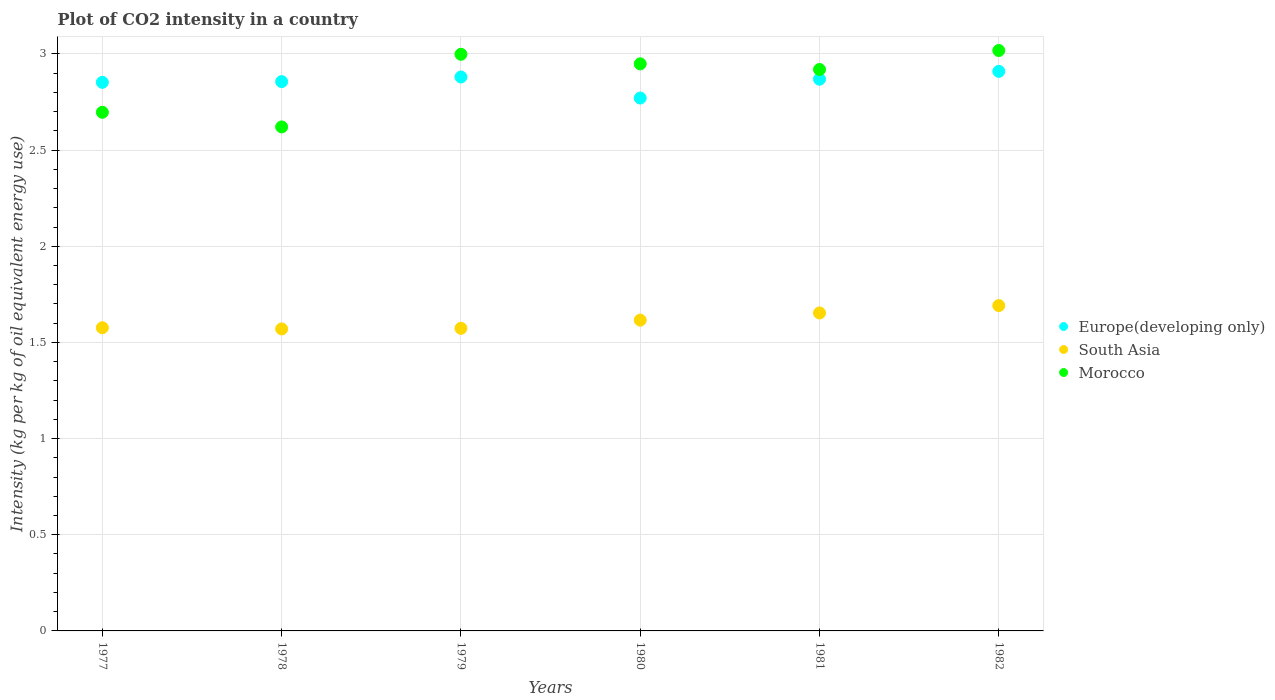How many different coloured dotlines are there?
Ensure brevity in your answer.  3. What is the CO2 intensity in in Europe(developing only) in 1980?
Keep it short and to the point. 2.77. Across all years, what is the maximum CO2 intensity in in South Asia?
Provide a short and direct response. 1.69. Across all years, what is the minimum CO2 intensity in in South Asia?
Your answer should be compact. 1.57. In which year was the CO2 intensity in in Morocco minimum?
Offer a very short reply. 1978. What is the total CO2 intensity in in Morocco in the graph?
Provide a short and direct response. 17.2. What is the difference between the CO2 intensity in in South Asia in 1978 and that in 1979?
Give a very brief answer. -0. What is the difference between the CO2 intensity in in Morocco in 1979 and the CO2 intensity in in South Asia in 1981?
Your answer should be very brief. 1.35. What is the average CO2 intensity in in South Asia per year?
Your response must be concise. 1.61. In the year 1980, what is the difference between the CO2 intensity in in Europe(developing only) and CO2 intensity in in Morocco?
Provide a succinct answer. -0.18. In how many years, is the CO2 intensity in in Morocco greater than 2 kg?
Make the answer very short. 6. What is the ratio of the CO2 intensity in in Morocco in 1979 to that in 1981?
Make the answer very short. 1.03. Is the difference between the CO2 intensity in in Europe(developing only) in 1979 and 1980 greater than the difference between the CO2 intensity in in Morocco in 1979 and 1980?
Provide a short and direct response. Yes. What is the difference between the highest and the second highest CO2 intensity in in Europe(developing only)?
Your answer should be compact. 0.03. What is the difference between the highest and the lowest CO2 intensity in in Europe(developing only)?
Your answer should be very brief. 0.14. In how many years, is the CO2 intensity in in Morocco greater than the average CO2 intensity in in Morocco taken over all years?
Offer a very short reply. 4. Is the sum of the CO2 intensity in in Europe(developing only) in 1977 and 1978 greater than the maximum CO2 intensity in in Morocco across all years?
Provide a succinct answer. Yes. Is it the case that in every year, the sum of the CO2 intensity in in Morocco and CO2 intensity in in South Asia  is greater than the CO2 intensity in in Europe(developing only)?
Make the answer very short. Yes. Does the CO2 intensity in in Morocco monotonically increase over the years?
Ensure brevity in your answer.  No. What is the difference between two consecutive major ticks on the Y-axis?
Your answer should be very brief. 0.5. Are the values on the major ticks of Y-axis written in scientific E-notation?
Provide a succinct answer. No. Does the graph contain any zero values?
Make the answer very short. No. Does the graph contain grids?
Your response must be concise. Yes. Where does the legend appear in the graph?
Provide a succinct answer. Center right. How are the legend labels stacked?
Keep it short and to the point. Vertical. What is the title of the graph?
Your answer should be compact. Plot of CO2 intensity in a country. What is the label or title of the X-axis?
Offer a terse response. Years. What is the label or title of the Y-axis?
Give a very brief answer. Intensity (kg per kg of oil equivalent energy use). What is the Intensity (kg per kg of oil equivalent energy use) of Europe(developing only) in 1977?
Offer a terse response. 2.85. What is the Intensity (kg per kg of oil equivalent energy use) in South Asia in 1977?
Keep it short and to the point. 1.58. What is the Intensity (kg per kg of oil equivalent energy use) in Morocco in 1977?
Provide a short and direct response. 2.7. What is the Intensity (kg per kg of oil equivalent energy use) in Europe(developing only) in 1978?
Ensure brevity in your answer.  2.86. What is the Intensity (kg per kg of oil equivalent energy use) of South Asia in 1978?
Ensure brevity in your answer.  1.57. What is the Intensity (kg per kg of oil equivalent energy use) in Morocco in 1978?
Provide a succinct answer. 2.62. What is the Intensity (kg per kg of oil equivalent energy use) of Europe(developing only) in 1979?
Provide a short and direct response. 2.88. What is the Intensity (kg per kg of oil equivalent energy use) of South Asia in 1979?
Offer a very short reply. 1.57. What is the Intensity (kg per kg of oil equivalent energy use) in Morocco in 1979?
Provide a succinct answer. 3. What is the Intensity (kg per kg of oil equivalent energy use) of Europe(developing only) in 1980?
Offer a very short reply. 2.77. What is the Intensity (kg per kg of oil equivalent energy use) in South Asia in 1980?
Keep it short and to the point. 1.62. What is the Intensity (kg per kg of oil equivalent energy use) of Morocco in 1980?
Your answer should be compact. 2.95. What is the Intensity (kg per kg of oil equivalent energy use) of Europe(developing only) in 1981?
Offer a very short reply. 2.87. What is the Intensity (kg per kg of oil equivalent energy use) of South Asia in 1981?
Give a very brief answer. 1.65. What is the Intensity (kg per kg of oil equivalent energy use) of Morocco in 1981?
Your answer should be very brief. 2.92. What is the Intensity (kg per kg of oil equivalent energy use) of Europe(developing only) in 1982?
Provide a short and direct response. 2.91. What is the Intensity (kg per kg of oil equivalent energy use) in South Asia in 1982?
Your answer should be very brief. 1.69. What is the Intensity (kg per kg of oil equivalent energy use) in Morocco in 1982?
Provide a short and direct response. 3.02. Across all years, what is the maximum Intensity (kg per kg of oil equivalent energy use) of Europe(developing only)?
Provide a succinct answer. 2.91. Across all years, what is the maximum Intensity (kg per kg of oil equivalent energy use) of South Asia?
Keep it short and to the point. 1.69. Across all years, what is the maximum Intensity (kg per kg of oil equivalent energy use) of Morocco?
Keep it short and to the point. 3.02. Across all years, what is the minimum Intensity (kg per kg of oil equivalent energy use) of Europe(developing only)?
Your answer should be compact. 2.77. Across all years, what is the minimum Intensity (kg per kg of oil equivalent energy use) in South Asia?
Your answer should be very brief. 1.57. Across all years, what is the minimum Intensity (kg per kg of oil equivalent energy use) of Morocco?
Give a very brief answer. 2.62. What is the total Intensity (kg per kg of oil equivalent energy use) of Europe(developing only) in the graph?
Offer a very short reply. 17.14. What is the total Intensity (kg per kg of oil equivalent energy use) of South Asia in the graph?
Provide a short and direct response. 9.68. What is the total Intensity (kg per kg of oil equivalent energy use) of Morocco in the graph?
Your response must be concise. 17.2. What is the difference between the Intensity (kg per kg of oil equivalent energy use) in Europe(developing only) in 1977 and that in 1978?
Keep it short and to the point. -0. What is the difference between the Intensity (kg per kg of oil equivalent energy use) of South Asia in 1977 and that in 1978?
Your response must be concise. 0.01. What is the difference between the Intensity (kg per kg of oil equivalent energy use) of Morocco in 1977 and that in 1978?
Your answer should be compact. 0.08. What is the difference between the Intensity (kg per kg of oil equivalent energy use) of Europe(developing only) in 1977 and that in 1979?
Your response must be concise. -0.03. What is the difference between the Intensity (kg per kg of oil equivalent energy use) of South Asia in 1977 and that in 1979?
Offer a very short reply. 0. What is the difference between the Intensity (kg per kg of oil equivalent energy use) in Morocco in 1977 and that in 1979?
Your response must be concise. -0.3. What is the difference between the Intensity (kg per kg of oil equivalent energy use) of Europe(developing only) in 1977 and that in 1980?
Your response must be concise. 0.08. What is the difference between the Intensity (kg per kg of oil equivalent energy use) of South Asia in 1977 and that in 1980?
Keep it short and to the point. -0.04. What is the difference between the Intensity (kg per kg of oil equivalent energy use) in Morocco in 1977 and that in 1980?
Your response must be concise. -0.25. What is the difference between the Intensity (kg per kg of oil equivalent energy use) in Europe(developing only) in 1977 and that in 1981?
Offer a very short reply. -0.02. What is the difference between the Intensity (kg per kg of oil equivalent energy use) in South Asia in 1977 and that in 1981?
Your response must be concise. -0.08. What is the difference between the Intensity (kg per kg of oil equivalent energy use) in Morocco in 1977 and that in 1981?
Offer a very short reply. -0.22. What is the difference between the Intensity (kg per kg of oil equivalent energy use) of Europe(developing only) in 1977 and that in 1982?
Make the answer very short. -0.06. What is the difference between the Intensity (kg per kg of oil equivalent energy use) in South Asia in 1977 and that in 1982?
Provide a succinct answer. -0.12. What is the difference between the Intensity (kg per kg of oil equivalent energy use) in Morocco in 1977 and that in 1982?
Provide a short and direct response. -0.32. What is the difference between the Intensity (kg per kg of oil equivalent energy use) in Europe(developing only) in 1978 and that in 1979?
Ensure brevity in your answer.  -0.02. What is the difference between the Intensity (kg per kg of oil equivalent energy use) of South Asia in 1978 and that in 1979?
Offer a terse response. -0. What is the difference between the Intensity (kg per kg of oil equivalent energy use) in Morocco in 1978 and that in 1979?
Offer a terse response. -0.38. What is the difference between the Intensity (kg per kg of oil equivalent energy use) in Europe(developing only) in 1978 and that in 1980?
Provide a short and direct response. 0.09. What is the difference between the Intensity (kg per kg of oil equivalent energy use) in South Asia in 1978 and that in 1980?
Provide a succinct answer. -0.05. What is the difference between the Intensity (kg per kg of oil equivalent energy use) of Morocco in 1978 and that in 1980?
Make the answer very short. -0.33. What is the difference between the Intensity (kg per kg of oil equivalent energy use) of Europe(developing only) in 1978 and that in 1981?
Provide a succinct answer. -0.01. What is the difference between the Intensity (kg per kg of oil equivalent energy use) of South Asia in 1978 and that in 1981?
Give a very brief answer. -0.08. What is the difference between the Intensity (kg per kg of oil equivalent energy use) in Morocco in 1978 and that in 1981?
Make the answer very short. -0.3. What is the difference between the Intensity (kg per kg of oil equivalent energy use) in Europe(developing only) in 1978 and that in 1982?
Your answer should be very brief. -0.05. What is the difference between the Intensity (kg per kg of oil equivalent energy use) of South Asia in 1978 and that in 1982?
Offer a terse response. -0.12. What is the difference between the Intensity (kg per kg of oil equivalent energy use) of Morocco in 1978 and that in 1982?
Ensure brevity in your answer.  -0.4. What is the difference between the Intensity (kg per kg of oil equivalent energy use) in Europe(developing only) in 1979 and that in 1980?
Give a very brief answer. 0.11. What is the difference between the Intensity (kg per kg of oil equivalent energy use) of South Asia in 1979 and that in 1980?
Provide a short and direct response. -0.04. What is the difference between the Intensity (kg per kg of oil equivalent energy use) in Morocco in 1979 and that in 1980?
Your response must be concise. 0.05. What is the difference between the Intensity (kg per kg of oil equivalent energy use) of Europe(developing only) in 1979 and that in 1981?
Offer a very short reply. 0.01. What is the difference between the Intensity (kg per kg of oil equivalent energy use) in South Asia in 1979 and that in 1981?
Ensure brevity in your answer.  -0.08. What is the difference between the Intensity (kg per kg of oil equivalent energy use) in Morocco in 1979 and that in 1981?
Keep it short and to the point. 0.08. What is the difference between the Intensity (kg per kg of oil equivalent energy use) in Europe(developing only) in 1979 and that in 1982?
Keep it short and to the point. -0.03. What is the difference between the Intensity (kg per kg of oil equivalent energy use) of South Asia in 1979 and that in 1982?
Give a very brief answer. -0.12. What is the difference between the Intensity (kg per kg of oil equivalent energy use) of Morocco in 1979 and that in 1982?
Provide a short and direct response. -0.02. What is the difference between the Intensity (kg per kg of oil equivalent energy use) of Europe(developing only) in 1980 and that in 1981?
Your answer should be very brief. -0.1. What is the difference between the Intensity (kg per kg of oil equivalent energy use) in South Asia in 1980 and that in 1981?
Give a very brief answer. -0.04. What is the difference between the Intensity (kg per kg of oil equivalent energy use) of Morocco in 1980 and that in 1981?
Your answer should be very brief. 0.03. What is the difference between the Intensity (kg per kg of oil equivalent energy use) in Europe(developing only) in 1980 and that in 1982?
Offer a terse response. -0.14. What is the difference between the Intensity (kg per kg of oil equivalent energy use) of South Asia in 1980 and that in 1982?
Provide a short and direct response. -0.08. What is the difference between the Intensity (kg per kg of oil equivalent energy use) in Morocco in 1980 and that in 1982?
Ensure brevity in your answer.  -0.07. What is the difference between the Intensity (kg per kg of oil equivalent energy use) of Europe(developing only) in 1981 and that in 1982?
Your response must be concise. -0.04. What is the difference between the Intensity (kg per kg of oil equivalent energy use) in South Asia in 1981 and that in 1982?
Give a very brief answer. -0.04. What is the difference between the Intensity (kg per kg of oil equivalent energy use) of Morocco in 1981 and that in 1982?
Make the answer very short. -0.1. What is the difference between the Intensity (kg per kg of oil equivalent energy use) of Europe(developing only) in 1977 and the Intensity (kg per kg of oil equivalent energy use) of South Asia in 1978?
Offer a terse response. 1.28. What is the difference between the Intensity (kg per kg of oil equivalent energy use) of Europe(developing only) in 1977 and the Intensity (kg per kg of oil equivalent energy use) of Morocco in 1978?
Give a very brief answer. 0.23. What is the difference between the Intensity (kg per kg of oil equivalent energy use) in South Asia in 1977 and the Intensity (kg per kg of oil equivalent energy use) in Morocco in 1978?
Give a very brief answer. -1.04. What is the difference between the Intensity (kg per kg of oil equivalent energy use) in Europe(developing only) in 1977 and the Intensity (kg per kg of oil equivalent energy use) in South Asia in 1979?
Keep it short and to the point. 1.28. What is the difference between the Intensity (kg per kg of oil equivalent energy use) in Europe(developing only) in 1977 and the Intensity (kg per kg of oil equivalent energy use) in Morocco in 1979?
Make the answer very short. -0.15. What is the difference between the Intensity (kg per kg of oil equivalent energy use) of South Asia in 1977 and the Intensity (kg per kg of oil equivalent energy use) of Morocco in 1979?
Offer a very short reply. -1.42. What is the difference between the Intensity (kg per kg of oil equivalent energy use) in Europe(developing only) in 1977 and the Intensity (kg per kg of oil equivalent energy use) in South Asia in 1980?
Offer a terse response. 1.24. What is the difference between the Intensity (kg per kg of oil equivalent energy use) in Europe(developing only) in 1977 and the Intensity (kg per kg of oil equivalent energy use) in Morocco in 1980?
Offer a very short reply. -0.1. What is the difference between the Intensity (kg per kg of oil equivalent energy use) in South Asia in 1977 and the Intensity (kg per kg of oil equivalent energy use) in Morocco in 1980?
Your answer should be compact. -1.37. What is the difference between the Intensity (kg per kg of oil equivalent energy use) of Europe(developing only) in 1977 and the Intensity (kg per kg of oil equivalent energy use) of South Asia in 1981?
Give a very brief answer. 1.2. What is the difference between the Intensity (kg per kg of oil equivalent energy use) in Europe(developing only) in 1977 and the Intensity (kg per kg of oil equivalent energy use) in Morocco in 1981?
Provide a succinct answer. -0.07. What is the difference between the Intensity (kg per kg of oil equivalent energy use) in South Asia in 1977 and the Intensity (kg per kg of oil equivalent energy use) in Morocco in 1981?
Your answer should be compact. -1.34. What is the difference between the Intensity (kg per kg of oil equivalent energy use) of Europe(developing only) in 1977 and the Intensity (kg per kg of oil equivalent energy use) of South Asia in 1982?
Provide a succinct answer. 1.16. What is the difference between the Intensity (kg per kg of oil equivalent energy use) of Europe(developing only) in 1977 and the Intensity (kg per kg of oil equivalent energy use) of Morocco in 1982?
Your response must be concise. -0.17. What is the difference between the Intensity (kg per kg of oil equivalent energy use) of South Asia in 1977 and the Intensity (kg per kg of oil equivalent energy use) of Morocco in 1982?
Make the answer very short. -1.44. What is the difference between the Intensity (kg per kg of oil equivalent energy use) in Europe(developing only) in 1978 and the Intensity (kg per kg of oil equivalent energy use) in South Asia in 1979?
Keep it short and to the point. 1.28. What is the difference between the Intensity (kg per kg of oil equivalent energy use) of Europe(developing only) in 1978 and the Intensity (kg per kg of oil equivalent energy use) of Morocco in 1979?
Provide a succinct answer. -0.14. What is the difference between the Intensity (kg per kg of oil equivalent energy use) in South Asia in 1978 and the Intensity (kg per kg of oil equivalent energy use) in Morocco in 1979?
Your answer should be compact. -1.43. What is the difference between the Intensity (kg per kg of oil equivalent energy use) in Europe(developing only) in 1978 and the Intensity (kg per kg of oil equivalent energy use) in South Asia in 1980?
Provide a short and direct response. 1.24. What is the difference between the Intensity (kg per kg of oil equivalent energy use) of Europe(developing only) in 1978 and the Intensity (kg per kg of oil equivalent energy use) of Morocco in 1980?
Keep it short and to the point. -0.09. What is the difference between the Intensity (kg per kg of oil equivalent energy use) of South Asia in 1978 and the Intensity (kg per kg of oil equivalent energy use) of Morocco in 1980?
Your answer should be compact. -1.38. What is the difference between the Intensity (kg per kg of oil equivalent energy use) in Europe(developing only) in 1978 and the Intensity (kg per kg of oil equivalent energy use) in South Asia in 1981?
Offer a terse response. 1.2. What is the difference between the Intensity (kg per kg of oil equivalent energy use) of Europe(developing only) in 1978 and the Intensity (kg per kg of oil equivalent energy use) of Morocco in 1981?
Offer a terse response. -0.06. What is the difference between the Intensity (kg per kg of oil equivalent energy use) of South Asia in 1978 and the Intensity (kg per kg of oil equivalent energy use) of Morocco in 1981?
Offer a terse response. -1.35. What is the difference between the Intensity (kg per kg of oil equivalent energy use) in Europe(developing only) in 1978 and the Intensity (kg per kg of oil equivalent energy use) in South Asia in 1982?
Ensure brevity in your answer.  1.16. What is the difference between the Intensity (kg per kg of oil equivalent energy use) in Europe(developing only) in 1978 and the Intensity (kg per kg of oil equivalent energy use) in Morocco in 1982?
Your answer should be compact. -0.16. What is the difference between the Intensity (kg per kg of oil equivalent energy use) in South Asia in 1978 and the Intensity (kg per kg of oil equivalent energy use) in Morocco in 1982?
Your answer should be very brief. -1.45. What is the difference between the Intensity (kg per kg of oil equivalent energy use) of Europe(developing only) in 1979 and the Intensity (kg per kg of oil equivalent energy use) of South Asia in 1980?
Your response must be concise. 1.26. What is the difference between the Intensity (kg per kg of oil equivalent energy use) in Europe(developing only) in 1979 and the Intensity (kg per kg of oil equivalent energy use) in Morocco in 1980?
Ensure brevity in your answer.  -0.07. What is the difference between the Intensity (kg per kg of oil equivalent energy use) in South Asia in 1979 and the Intensity (kg per kg of oil equivalent energy use) in Morocco in 1980?
Offer a very short reply. -1.38. What is the difference between the Intensity (kg per kg of oil equivalent energy use) of Europe(developing only) in 1979 and the Intensity (kg per kg of oil equivalent energy use) of South Asia in 1981?
Keep it short and to the point. 1.23. What is the difference between the Intensity (kg per kg of oil equivalent energy use) in Europe(developing only) in 1979 and the Intensity (kg per kg of oil equivalent energy use) in Morocco in 1981?
Your response must be concise. -0.04. What is the difference between the Intensity (kg per kg of oil equivalent energy use) of South Asia in 1979 and the Intensity (kg per kg of oil equivalent energy use) of Morocco in 1981?
Provide a succinct answer. -1.35. What is the difference between the Intensity (kg per kg of oil equivalent energy use) of Europe(developing only) in 1979 and the Intensity (kg per kg of oil equivalent energy use) of South Asia in 1982?
Offer a very short reply. 1.19. What is the difference between the Intensity (kg per kg of oil equivalent energy use) in Europe(developing only) in 1979 and the Intensity (kg per kg of oil equivalent energy use) in Morocco in 1982?
Offer a terse response. -0.14. What is the difference between the Intensity (kg per kg of oil equivalent energy use) in South Asia in 1979 and the Intensity (kg per kg of oil equivalent energy use) in Morocco in 1982?
Provide a short and direct response. -1.44. What is the difference between the Intensity (kg per kg of oil equivalent energy use) in Europe(developing only) in 1980 and the Intensity (kg per kg of oil equivalent energy use) in South Asia in 1981?
Your answer should be compact. 1.12. What is the difference between the Intensity (kg per kg of oil equivalent energy use) in Europe(developing only) in 1980 and the Intensity (kg per kg of oil equivalent energy use) in Morocco in 1981?
Provide a succinct answer. -0.15. What is the difference between the Intensity (kg per kg of oil equivalent energy use) of South Asia in 1980 and the Intensity (kg per kg of oil equivalent energy use) of Morocco in 1981?
Ensure brevity in your answer.  -1.3. What is the difference between the Intensity (kg per kg of oil equivalent energy use) in Europe(developing only) in 1980 and the Intensity (kg per kg of oil equivalent energy use) in South Asia in 1982?
Ensure brevity in your answer.  1.08. What is the difference between the Intensity (kg per kg of oil equivalent energy use) of Europe(developing only) in 1980 and the Intensity (kg per kg of oil equivalent energy use) of Morocco in 1982?
Give a very brief answer. -0.25. What is the difference between the Intensity (kg per kg of oil equivalent energy use) of South Asia in 1980 and the Intensity (kg per kg of oil equivalent energy use) of Morocco in 1982?
Your answer should be compact. -1.4. What is the difference between the Intensity (kg per kg of oil equivalent energy use) in Europe(developing only) in 1981 and the Intensity (kg per kg of oil equivalent energy use) in South Asia in 1982?
Offer a very short reply. 1.18. What is the difference between the Intensity (kg per kg of oil equivalent energy use) in Europe(developing only) in 1981 and the Intensity (kg per kg of oil equivalent energy use) in Morocco in 1982?
Your response must be concise. -0.15. What is the difference between the Intensity (kg per kg of oil equivalent energy use) of South Asia in 1981 and the Intensity (kg per kg of oil equivalent energy use) of Morocco in 1982?
Make the answer very short. -1.36. What is the average Intensity (kg per kg of oil equivalent energy use) of Europe(developing only) per year?
Keep it short and to the point. 2.86. What is the average Intensity (kg per kg of oil equivalent energy use) in South Asia per year?
Your response must be concise. 1.61. What is the average Intensity (kg per kg of oil equivalent energy use) of Morocco per year?
Keep it short and to the point. 2.87. In the year 1977, what is the difference between the Intensity (kg per kg of oil equivalent energy use) in Europe(developing only) and Intensity (kg per kg of oil equivalent energy use) in South Asia?
Provide a short and direct response. 1.28. In the year 1977, what is the difference between the Intensity (kg per kg of oil equivalent energy use) in Europe(developing only) and Intensity (kg per kg of oil equivalent energy use) in Morocco?
Your answer should be compact. 0.16. In the year 1977, what is the difference between the Intensity (kg per kg of oil equivalent energy use) of South Asia and Intensity (kg per kg of oil equivalent energy use) of Morocco?
Give a very brief answer. -1.12. In the year 1978, what is the difference between the Intensity (kg per kg of oil equivalent energy use) of Europe(developing only) and Intensity (kg per kg of oil equivalent energy use) of South Asia?
Your answer should be compact. 1.29. In the year 1978, what is the difference between the Intensity (kg per kg of oil equivalent energy use) in Europe(developing only) and Intensity (kg per kg of oil equivalent energy use) in Morocco?
Offer a terse response. 0.24. In the year 1978, what is the difference between the Intensity (kg per kg of oil equivalent energy use) of South Asia and Intensity (kg per kg of oil equivalent energy use) of Morocco?
Give a very brief answer. -1.05. In the year 1979, what is the difference between the Intensity (kg per kg of oil equivalent energy use) in Europe(developing only) and Intensity (kg per kg of oil equivalent energy use) in South Asia?
Keep it short and to the point. 1.31. In the year 1979, what is the difference between the Intensity (kg per kg of oil equivalent energy use) in Europe(developing only) and Intensity (kg per kg of oil equivalent energy use) in Morocco?
Offer a very short reply. -0.12. In the year 1979, what is the difference between the Intensity (kg per kg of oil equivalent energy use) of South Asia and Intensity (kg per kg of oil equivalent energy use) of Morocco?
Ensure brevity in your answer.  -1.42. In the year 1980, what is the difference between the Intensity (kg per kg of oil equivalent energy use) in Europe(developing only) and Intensity (kg per kg of oil equivalent energy use) in South Asia?
Offer a very short reply. 1.15. In the year 1980, what is the difference between the Intensity (kg per kg of oil equivalent energy use) in Europe(developing only) and Intensity (kg per kg of oil equivalent energy use) in Morocco?
Your answer should be very brief. -0.18. In the year 1980, what is the difference between the Intensity (kg per kg of oil equivalent energy use) of South Asia and Intensity (kg per kg of oil equivalent energy use) of Morocco?
Offer a very short reply. -1.33. In the year 1981, what is the difference between the Intensity (kg per kg of oil equivalent energy use) of Europe(developing only) and Intensity (kg per kg of oil equivalent energy use) of South Asia?
Your response must be concise. 1.22. In the year 1981, what is the difference between the Intensity (kg per kg of oil equivalent energy use) in Europe(developing only) and Intensity (kg per kg of oil equivalent energy use) in Morocco?
Your answer should be compact. -0.05. In the year 1981, what is the difference between the Intensity (kg per kg of oil equivalent energy use) of South Asia and Intensity (kg per kg of oil equivalent energy use) of Morocco?
Provide a succinct answer. -1.27. In the year 1982, what is the difference between the Intensity (kg per kg of oil equivalent energy use) in Europe(developing only) and Intensity (kg per kg of oil equivalent energy use) in South Asia?
Offer a very short reply. 1.22. In the year 1982, what is the difference between the Intensity (kg per kg of oil equivalent energy use) in Europe(developing only) and Intensity (kg per kg of oil equivalent energy use) in Morocco?
Make the answer very short. -0.11. In the year 1982, what is the difference between the Intensity (kg per kg of oil equivalent energy use) of South Asia and Intensity (kg per kg of oil equivalent energy use) of Morocco?
Provide a short and direct response. -1.33. What is the ratio of the Intensity (kg per kg of oil equivalent energy use) of South Asia in 1977 to that in 1979?
Your response must be concise. 1. What is the ratio of the Intensity (kg per kg of oil equivalent energy use) of Morocco in 1977 to that in 1979?
Offer a terse response. 0.9. What is the ratio of the Intensity (kg per kg of oil equivalent energy use) of Europe(developing only) in 1977 to that in 1980?
Ensure brevity in your answer.  1.03. What is the ratio of the Intensity (kg per kg of oil equivalent energy use) of South Asia in 1977 to that in 1980?
Give a very brief answer. 0.98. What is the ratio of the Intensity (kg per kg of oil equivalent energy use) in Morocco in 1977 to that in 1980?
Provide a short and direct response. 0.91. What is the ratio of the Intensity (kg per kg of oil equivalent energy use) in Europe(developing only) in 1977 to that in 1981?
Make the answer very short. 0.99. What is the ratio of the Intensity (kg per kg of oil equivalent energy use) in South Asia in 1977 to that in 1981?
Make the answer very short. 0.95. What is the ratio of the Intensity (kg per kg of oil equivalent energy use) in Morocco in 1977 to that in 1981?
Offer a very short reply. 0.92. What is the ratio of the Intensity (kg per kg of oil equivalent energy use) in Europe(developing only) in 1977 to that in 1982?
Your answer should be very brief. 0.98. What is the ratio of the Intensity (kg per kg of oil equivalent energy use) of South Asia in 1977 to that in 1982?
Your response must be concise. 0.93. What is the ratio of the Intensity (kg per kg of oil equivalent energy use) in Morocco in 1977 to that in 1982?
Offer a terse response. 0.89. What is the ratio of the Intensity (kg per kg of oil equivalent energy use) of Europe(developing only) in 1978 to that in 1979?
Your answer should be very brief. 0.99. What is the ratio of the Intensity (kg per kg of oil equivalent energy use) of Morocco in 1978 to that in 1979?
Provide a short and direct response. 0.87. What is the ratio of the Intensity (kg per kg of oil equivalent energy use) of Europe(developing only) in 1978 to that in 1980?
Your answer should be compact. 1.03. What is the ratio of the Intensity (kg per kg of oil equivalent energy use) in South Asia in 1978 to that in 1980?
Offer a terse response. 0.97. What is the ratio of the Intensity (kg per kg of oil equivalent energy use) of Morocco in 1978 to that in 1980?
Your answer should be compact. 0.89. What is the ratio of the Intensity (kg per kg of oil equivalent energy use) of Europe(developing only) in 1978 to that in 1981?
Give a very brief answer. 1. What is the ratio of the Intensity (kg per kg of oil equivalent energy use) in South Asia in 1978 to that in 1981?
Keep it short and to the point. 0.95. What is the ratio of the Intensity (kg per kg of oil equivalent energy use) of Morocco in 1978 to that in 1981?
Provide a short and direct response. 0.9. What is the ratio of the Intensity (kg per kg of oil equivalent energy use) of Europe(developing only) in 1978 to that in 1982?
Ensure brevity in your answer.  0.98. What is the ratio of the Intensity (kg per kg of oil equivalent energy use) of South Asia in 1978 to that in 1982?
Ensure brevity in your answer.  0.93. What is the ratio of the Intensity (kg per kg of oil equivalent energy use) of Morocco in 1978 to that in 1982?
Your answer should be compact. 0.87. What is the ratio of the Intensity (kg per kg of oil equivalent energy use) of Europe(developing only) in 1979 to that in 1980?
Offer a very short reply. 1.04. What is the ratio of the Intensity (kg per kg of oil equivalent energy use) of South Asia in 1979 to that in 1980?
Provide a succinct answer. 0.97. What is the ratio of the Intensity (kg per kg of oil equivalent energy use) of Morocco in 1979 to that in 1980?
Offer a very short reply. 1.02. What is the ratio of the Intensity (kg per kg of oil equivalent energy use) in Europe(developing only) in 1979 to that in 1981?
Ensure brevity in your answer.  1. What is the ratio of the Intensity (kg per kg of oil equivalent energy use) of South Asia in 1979 to that in 1981?
Offer a very short reply. 0.95. What is the ratio of the Intensity (kg per kg of oil equivalent energy use) of Morocco in 1979 to that in 1981?
Your answer should be very brief. 1.03. What is the ratio of the Intensity (kg per kg of oil equivalent energy use) of Europe(developing only) in 1979 to that in 1982?
Keep it short and to the point. 0.99. What is the ratio of the Intensity (kg per kg of oil equivalent energy use) in South Asia in 1979 to that in 1982?
Keep it short and to the point. 0.93. What is the ratio of the Intensity (kg per kg of oil equivalent energy use) of Europe(developing only) in 1980 to that in 1981?
Your answer should be very brief. 0.97. What is the ratio of the Intensity (kg per kg of oil equivalent energy use) of South Asia in 1980 to that in 1981?
Your response must be concise. 0.98. What is the ratio of the Intensity (kg per kg of oil equivalent energy use) of Europe(developing only) in 1980 to that in 1982?
Offer a very short reply. 0.95. What is the ratio of the Intensity (kg per kg of oil equivalent energy use) in South Asia in 1980 to that in 1982?
Make the answer very short. 0.96. What is the ratio of the Intensity (kg per kg of oil equivalent energy use) in Morocco in 1980 to that in 1982?
Keep it short and to the point. 0.98. What is the ratio of the Intensity (kg per kg of oil equivalent energy use) in Europe(developing only) in 1981 to that in 1982?
Provide a succinct answer. 0.99. What is the ratio of the Intensity (kg per kg of oil equivalent energy use) of South Asia in 1981 to that in 1982?
Provide a short and direct response. 0.98. What is the ratio of the Intensity (kg per kg of oil equivalent energy use) in Morocco in 1981 to that in 1982?
Provide a succinct answer. 0.97. What is the difference between the highest and the second highest Intensity (kg per kg of oil equivalent energy use) in Europe(developing only)?
Your answer should be compact. 0.03. What is the difference between the highest and the second highest Intensity (kg per kg of oil equivalent energy use) of South Asia?
Keep it short and to the point. 0.04. What is the difference between the highest and the second highest Intensity (kg per kg of oil equivalent energy use) of Morocco?
Your answer should be compact. 0.02. What is the difference between the highest and the lowest Intensity (kg per kg of oil equivalent energy use) of Europe(developing only)?
Your answer should be very brief. 0.14. What is the difference between the highest and the lowest Intensity (kg per kg of oil equivalent energy use) in South Asia?
Your answer should be very brief. 0.12. What is the difference between the highest and the lowest Intensity (kg per kg of oil equivalent energy use) of Morocco?
Make the answer very short. 0.4. 